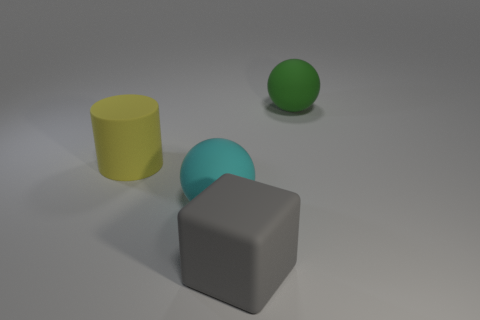Add 2 red metallic cylinders. How many objects exist? 6 Subtract all cylinders. How many objects are left? 3 Add 4 large matte objects. How many large matte objects exist? 8 Subtract 0 brown blocks. How many objects are left? 4 Subtract all large gray objects. Subtract all green shiny blocks. How many objects are left? 3 Add 3 big cubes. How many big cubes are left? 4 